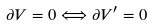<formula> <loc_0><loc_0><loc_500><loc_500>\partial V = 0 \Longleftrightarrow \partial V ^ { \prime } = 0</formula> 